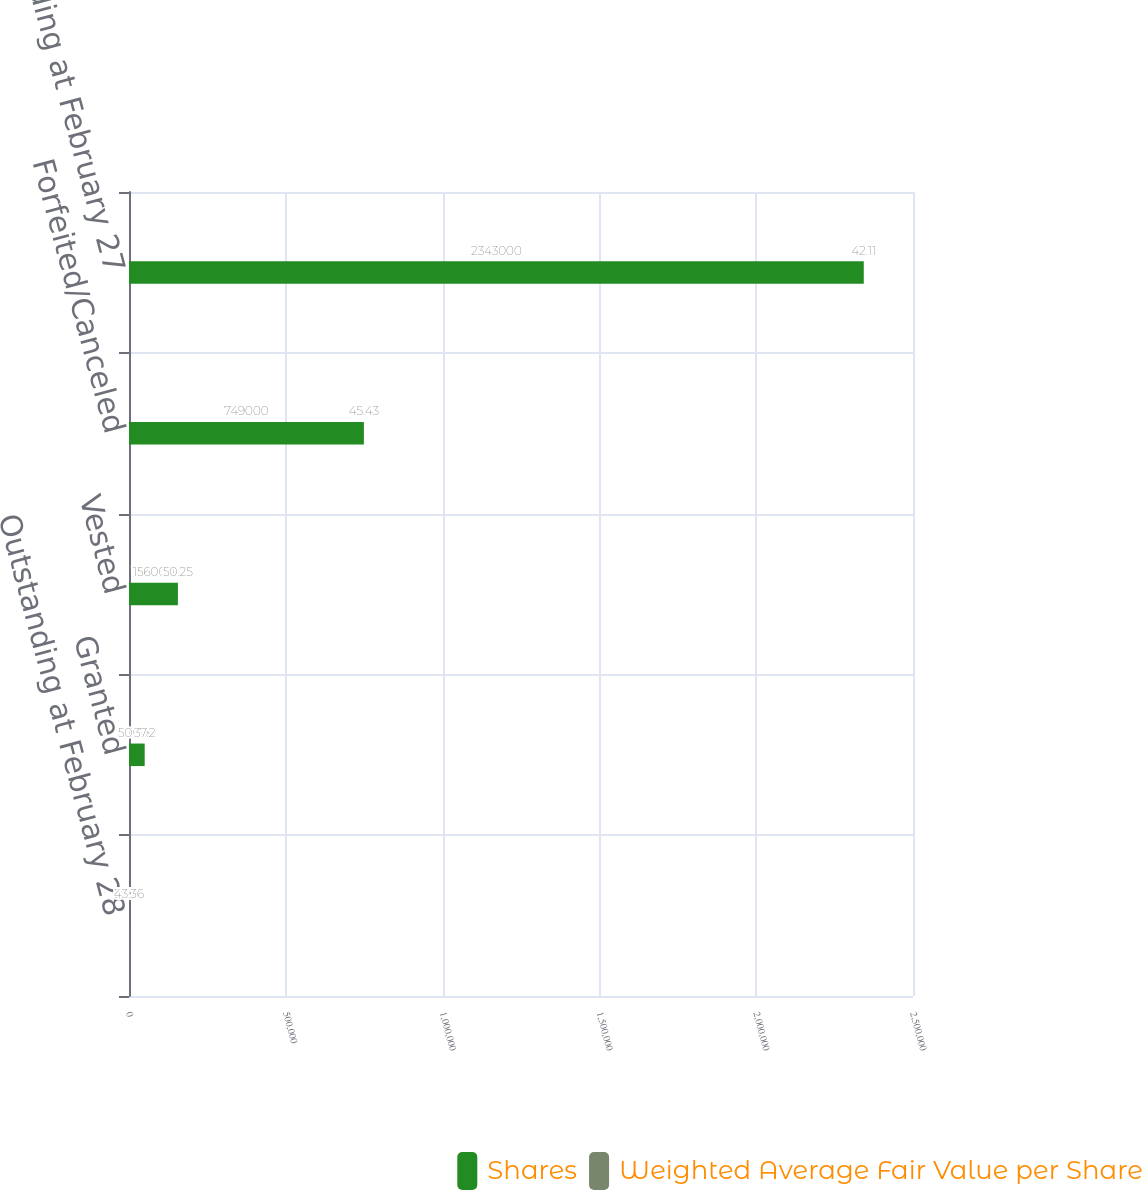Convert chart. <chart><loc_0><loc_0><loc_500><loc_500><stacked_bar_chart><ecel><fcel>Outstanding at February 28<fcel>Granted<fcel>Vested<fcel>Forfeited/Canceled<fcel>Outstanding at February 27<nl><fcel>Shares<fcel>50.25<fcel>50000<fcel>156000<fcel>749000<fcel>2.343e+06<nl><fcel>Weighted Average Fair Value per Share<fcel>43.36<fcel>37.2<fcel>50.25<fcel>45.43<fcel>42.11<nl></chart> 